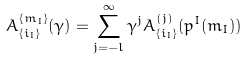Convert formula to latex. <formula><loc_0><loc_0><loc_500><loc_500>A _ { \{ i _ { I } \} } ^ { \{ m _ { I } \} } ( \gamma ) = \sum _ { j = - l } ^ { \infty } \gamma ^ { j } A ^ { ( j ) } _ { \{ i _ { I } \} } ( p ^ { I } ( m _ { I } ) )</formula> 